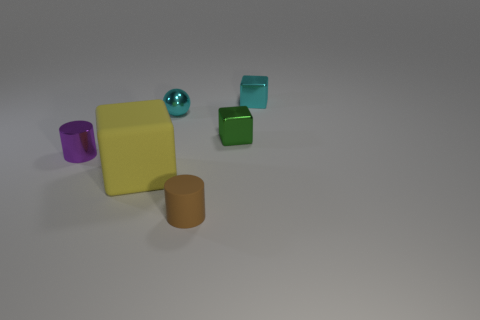How many green objects are either tiny shiny objects or small blocks? In the image, there appears to be a total of two green objects of note: one small, shiny sphere and one small, green block. Assessing the objects based on the question's criteria, it could be said that there is one green tiny shiny object, the sphere, and one small green block, meeting the description provided. 